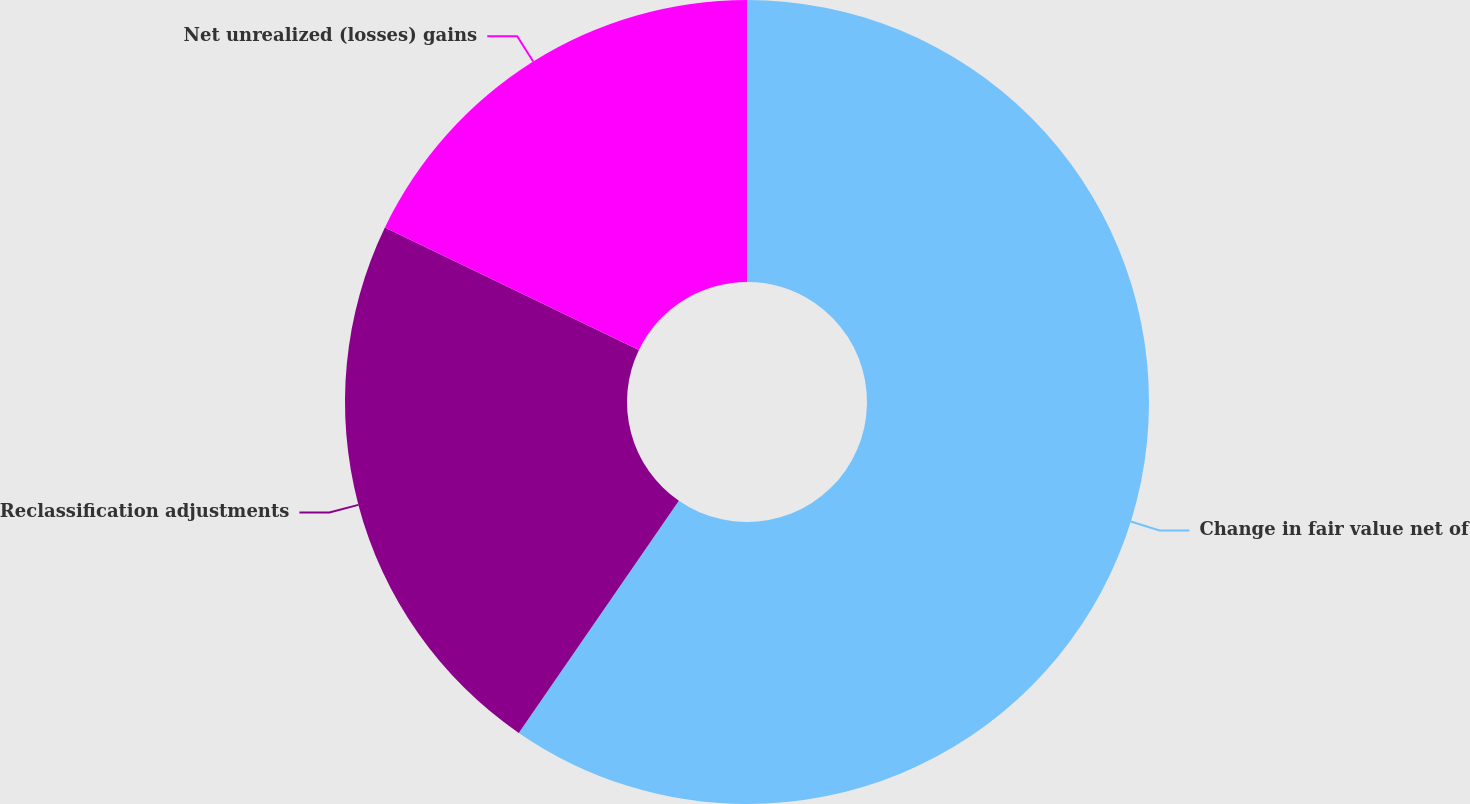Convert chart. <chart><loc_0><loc_0><loc_500><loc_500><pie_chart><fcel>Change in fair value net of<fcel>Reclassification adjustments<fcel>Net unrealized (losses) gains<nl><fcel>59.61%<fcel>22.54%<fcel>17.85%<nl></chart> 